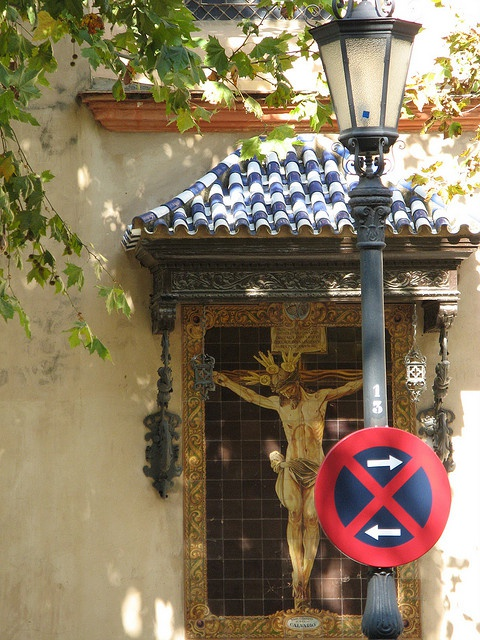Describe the objects in this image and their specific colors. I can see various objects in this image with different colors. 